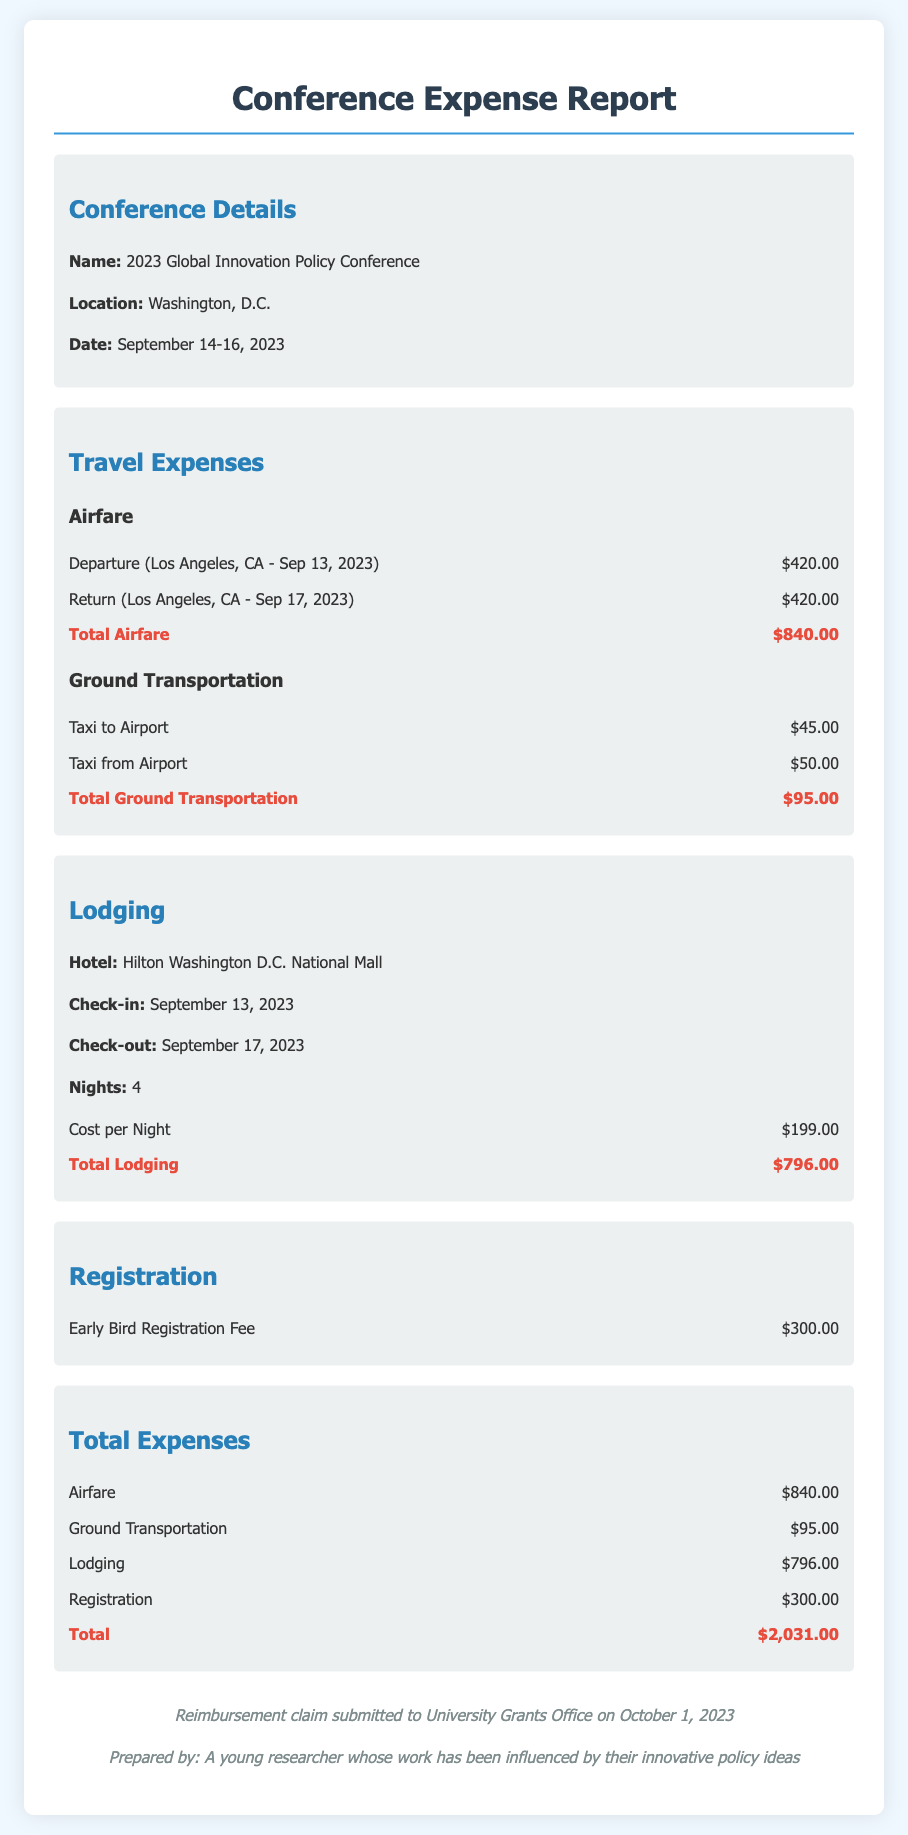What is the total airfare cost? The total airfare cost is provided in the document under the Travel Expenses section, which adds the departure and return costs.
Answer: $840.00 What is the cost per night for lodging? The cost per night is listed in the Lodging section of the document, providing a specific amount for each night of stay.
Answer: $199.00 What are the check-in and check-out dates? The check-in and check-out dates for lodging are stated in the Lodging section, which specifies when the researcher stayed at the hotel.
Answer: September 13, 2023 and September 17, 2023 What was the total cost of ground transportation? The total cost of ground transportation is derived from adding both taxi costs listed in the Travel Expenses section.
Answer: $95.00 What registration fee was paid? The registration fee is mentioned in the Registration section of the expense report, detailing the amount paid for attending the conference.
Answer: $300.00 What is the total amount of expenses listed? The total amount of expenses is calculated from all costs indicated in the document across various sections listed in the Total Expenses.
Answer: $2,031.00 When was the reimbursement claim submitted? The submission date for the reimbursement claim is stated in the footer of the document, providing the exact date it was submitted to the University Grants Office.
Answer: October 1, 2023 Where was the conference held? The location of the conference is specified in the Conference Details section of the document.
Answer: Washington, D.C How many nights was lodging booked? The number of nights for which lodging was booked is specified in the Lodging section of the document.
Answer: 4 